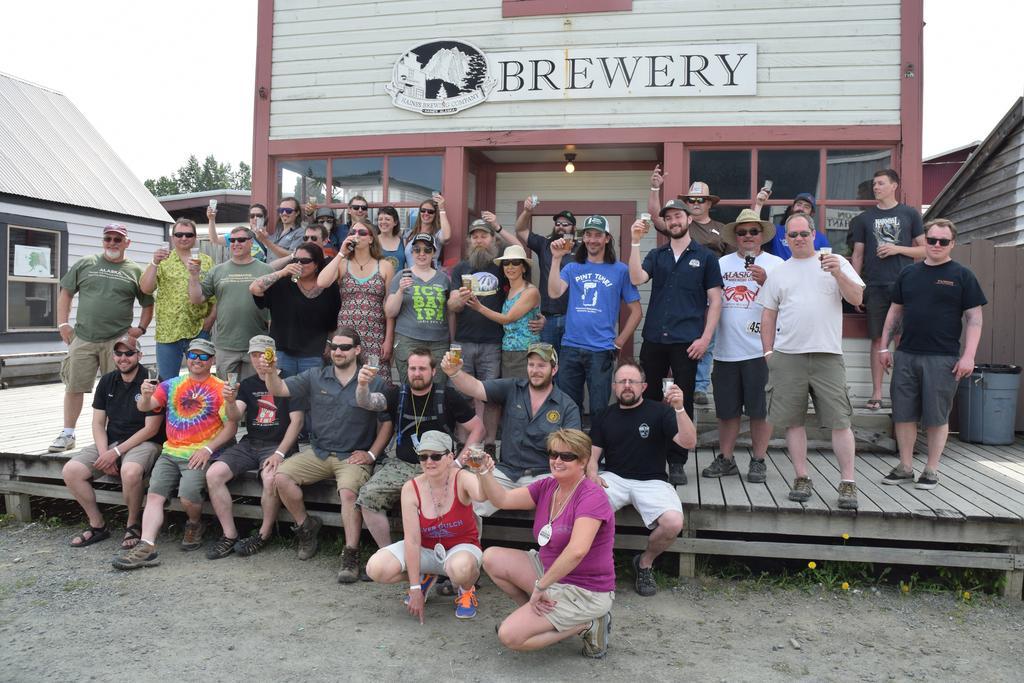How would you summarize this image in a sentence or two? In this image in front there are a few people sitting on the wooden platform by holding the glasses. Behind them there are a few people standing. In the background of the image there are buildings, trees and sky. In the center of the image there is a light. On the right side of the image there is a dustbin. 